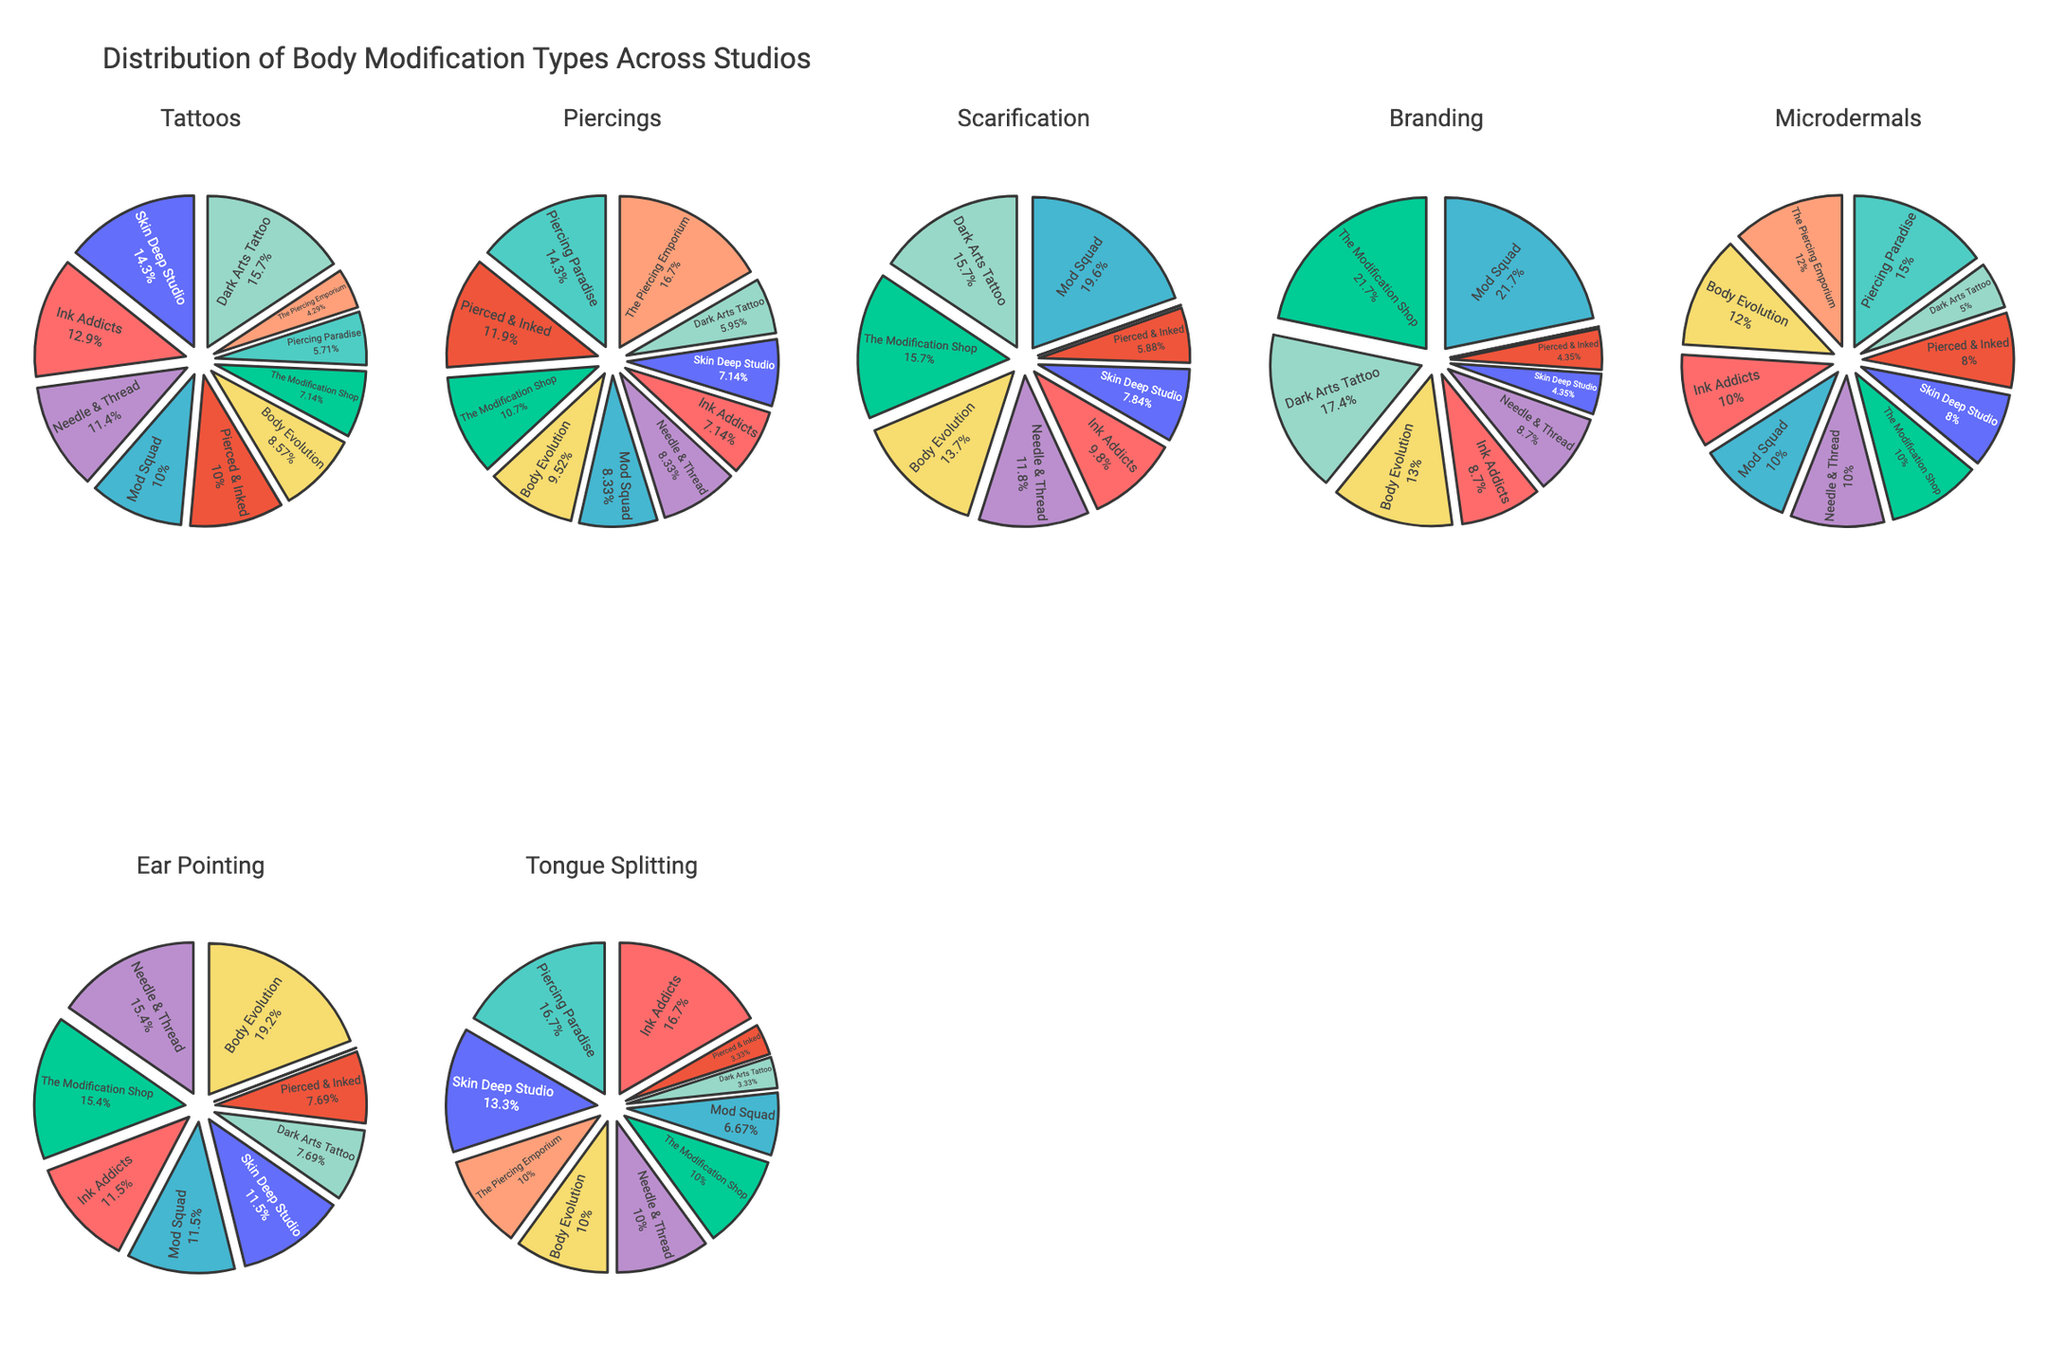What's the title of the figure? The title is displayed at the top of the figure and summarizes the contents. It reads "<b>Correlation Matrix: Lifestyle Factors and Cancer Risk</b>".
Answer: Correlation Matrix: Lifestyle Factors and Cancer Risk How many genetic risk scores are shown in the figure? By looking at the axis labels, especially where "Genetic Risk Score" is plotted, we observe three different Genetic Risk Scores (65, 80, 95).
Answer: 3 Are there more data points for high or low genetic risk scores? "High" genetic risk scores refer to the highest value we see, which is 95. Observing the scatter matrix, each colored group (Lifestyle Factor) has an equal number of data points for each Genetic Risk Score, indicating no overall imbalance. Therefore, the number of points from each risk group is equal.
Answer: Equal Which lifestyle factor is associated with the highest cancer incidence rate for genetic risk score 95? By focusing on the data points colored differently for each Lifestyle Factor in the scatter plot involving "Genetic Risk Score" 95 and "Cancer Incidence Rate", the data point with the highest cancer rate falls under "Smoking Pack Years".
Answer: Smoking Pack Years How does the relationship between daily exercise and cancer incidence vary across different genetic risk scores? We need to look at the scatter plots involving "Daily Exercise Minutes" and "Cancer Incidence Rate" for each "Genetic Risk Score". As genetic risk score increases (65, 80, 95), the cancer incidence rate generally increases even though daily exercise minutes vary, showing a stronger effect of genetic risk on cancer incidence.
Answer: Generally increases What trend can be observed between Fruit/Veg Servings Daily and Age of Onset of Cancer? Observing the scatter plots between "Fruit/Veg Servings Daily" and "Age of Onset", an upward trend can be seen. Higher servings of fruits and vegetables daily seem to be associated with a higher age of onset.
Answer: Higher servings, higher age of onset Is there any correlation between Family History Strength and Genetic Risk Score? By examining the scatter plots between "Family History Strength" and "Genetic Risk Score", we can see a positive correlation where stronger family history aligns with higher genetic risk scores.
Answer: Positive correlation Which lifestyle factor appears least associated with the Age of Onset of cancer? Observing the scatter plots involving "Age of Onset", "Alcohol Units Weekly" seems to have a less consistent trend across different genetic risk scores, indicating weaker association compared to others.
Answer: Alcohol Units Weekly How does smoking pack years affect cancer incidence rate based on the plot? Looking at the plots of "Smoking Pack Years" versus "Cancer Incidence Rate", there appears to be a clear positive relationship; as smoking pack years increase, cancer incidence rate increases.
Answer: Positive relationship Which two lifestyle factors show strong variation in cancer incidence rate for genetic risk score 80? Observing the points specific to genetic risk score 80 in the scatter plots of "Cancer Incidence Rate", "Smoking Pack Years" and "Alcohol Units Weekly" show strong variation, indicating different cancer rates in these two factors compared to others.
Answer: Smoking Pack Years, Alcohol Units Weekly 